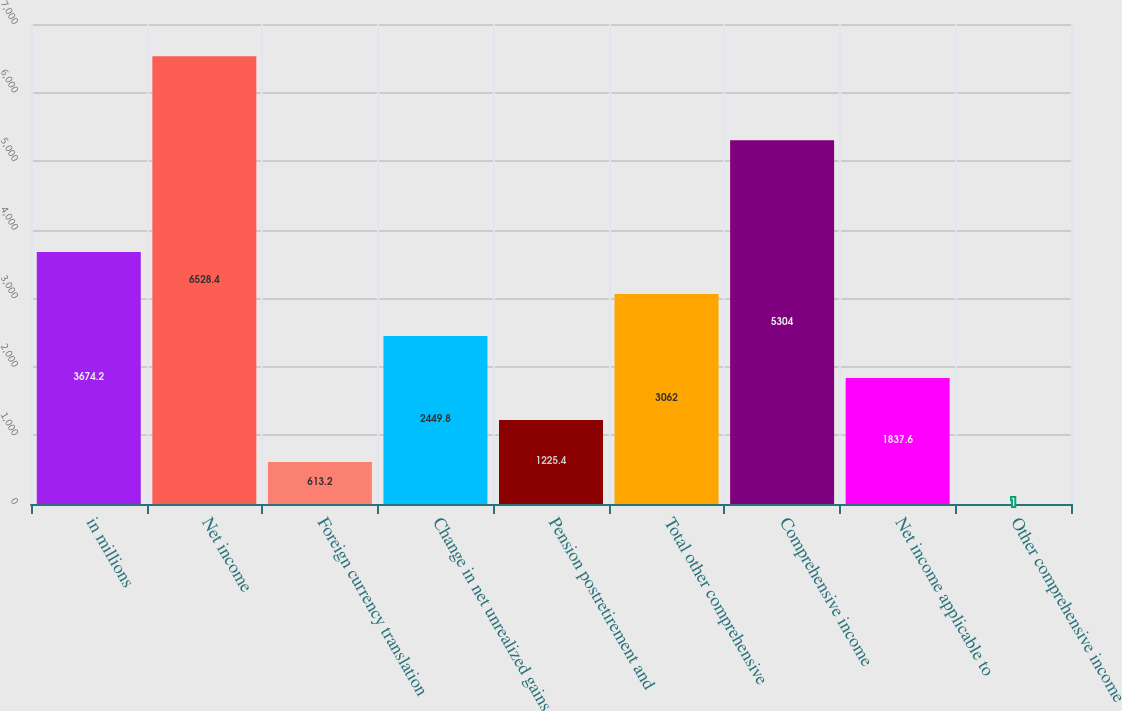Convert chart to OTSL. <chart><loc_0><loc_0><loc_500><loc_500><bar_chart><fcel>in millions<fcel>Net income<fcel>Foreign currency translation<fcel>Change in net unrealized gains<fcel>Pension postretirement and<fcel>Total other comprehensive<fcel>Comprehensive income<fcel>Net income applicable to<fcel>Other comprehensive income<nl><fcel>3674.2<fcel>6528.4<fcel>613.2<fcel>2449.8<fcel>1225.4<fcel>3062<fcel>5304<fcel>1837.6<fcel>1<nl></chart> 